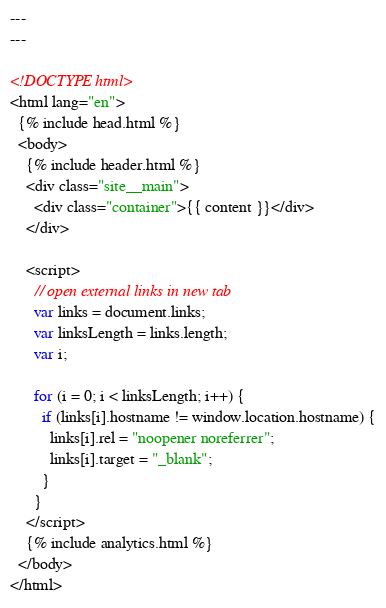<code> <loc_0><loc_0><loc_500><loc_500><_HTML_>---
---

<!DOCTYPE html>
<html lang="en">
  {% include head.html %}
  <body>
    {% include header.html %}
    <div class="site__main">
      <div class="container">{{ content }}</div>
    </div>

    <script>
      // open external links in new tab
      var links = document.links;
      var linksLength = links.length;
      var i;

      for (i = 0; i < linksLength; i++) {
        if (links[i].hostname != window.location.hostname) {
          links[i].rel = "noopener noreferrer";
          links[i].target = "_blank";
        }
      }
    </script>
    {% include analytics.html %}
  </body>
</html></code> 